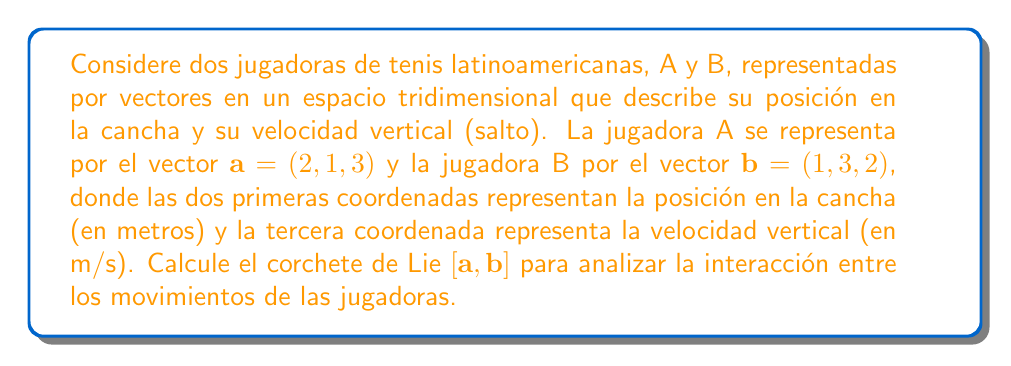Show me your answer to this math problem. Para calcular el corchete de Lie de dos vectores en $\mathbb{R}^3$, utilizamos la fórmula del producto cruz:

$[\mathbf{a}, \mathbf{b}] = \mathbf{a} \times \mathbf{b}$

Donde $\times$ denota el producto cruz en tres dimensiones.

El producto cruz se calcula de la siguiente manera:

$$\mathbf{a} \times \mathbf{b} = \begin{vmatrix} 
\mathbf{i} & \mathbf{j} & \mathbf{k} \\
a_1 & a_2 & a_3 \\
b_1 & b_2 & b_3
\end{vmatrix}$$

Donde $\mathbf{i}$, $\mathbf{j}$, y $\mathbf{k}$ son los vectores unitarios en las direcciones x, y, y z respectivamente.

Sustituyendo los valores dados:

$$[\mathbf{a}, \mathbf{b}] = \begin{vmatrix} 
\mathbf{i} & \mathbf{j} & \mathbf{k} \\
2 & 1 & 3 \\
1 & 3 & 2
\end{vmatrix}$$

Calculando los componentes:

1) $i: (1)(2) - (3)(3) = 2 - 9 = -7$
2) $j: (2)(2) - (1)(1) = 4 - 1 = 3$
3) $k: (2)(3) - (1)(1) = 6 - 1 = 5$

Por lo tanto, el corchete de Lie es:

$[\mathbf{a}, \mathbf{b}] = (-7, 3, 5)$

Este resultado representa la interacción entre los movimientos de las jugadoras A y B. El componente negativo en x indica un movimiento opuesto en esa dirección, mientras que los componentes positivos en y y z sugieren movimientos similares en esas direcciones.
Answer: $[\mathbf{a}, \mathbf{b}] = (-7, 3, 5)$ 